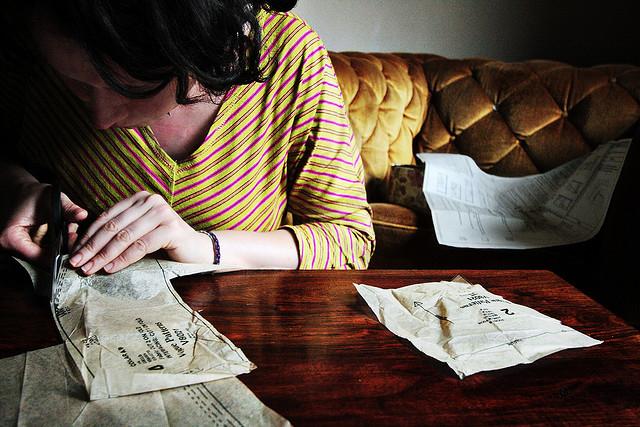What is behind the woman?
Quick response, please. Couch. Is this woman at a restaurant?
Give a very brief answer. No. What is the person doing to the bag?
Write a very short answer. Cutting. What is this person doing?
Quick response, please. Cutting. What tool is she using?
Quick response, please. Scissors. 